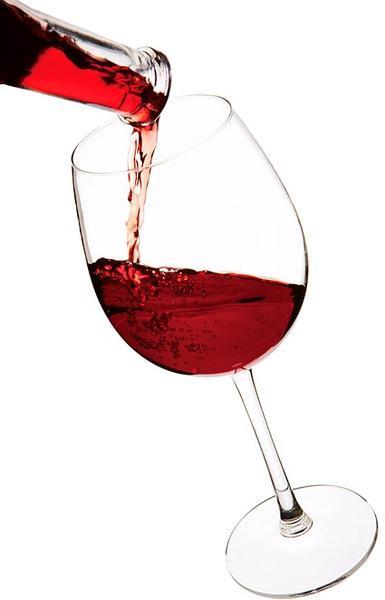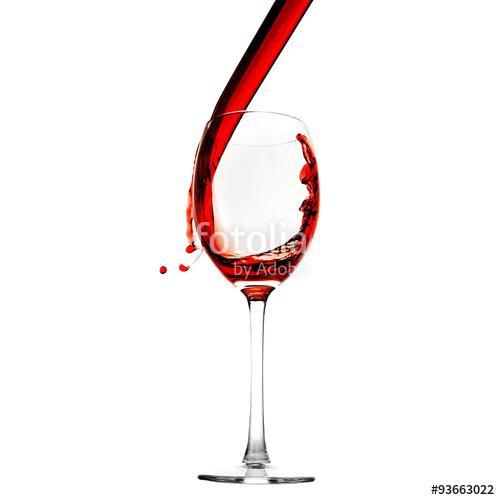The first image is the image on the left, the second image is the image on the right. Given the left and right images, does the statement "The neck of the bottle is near a glass." hold true? Answer yes or no. Yes. 